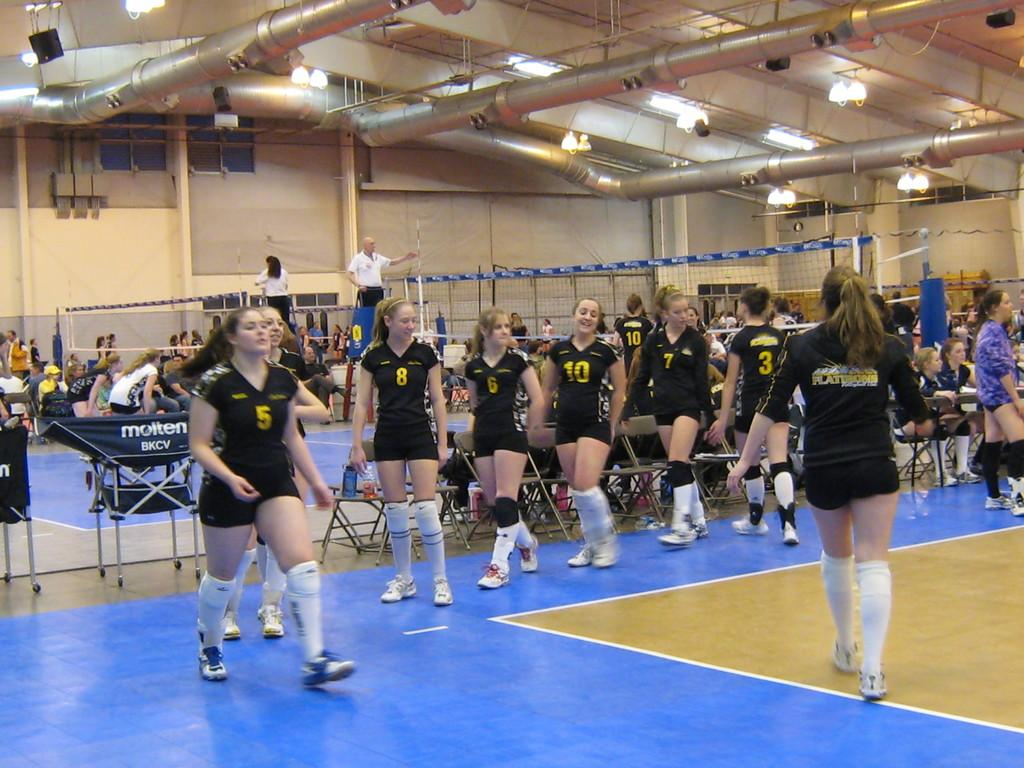<image>
Create a compact narrative representing the image presented. a volleyball team with one player wearing the number 5 jersey 